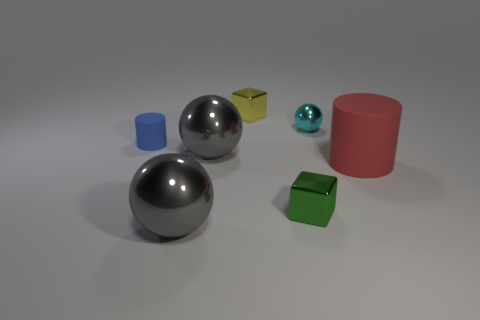How many red rubber things are behind the small blue cylinder?
Your response must be concise. 0. Does the tiny cube in front of the blue matte object have the same color as the big cylinder?
Your answer should be very brief. No. How many blue objects are either small rubber objects or big things?
Give a very brief answer. 1. There is a tiny cylinder that is left of the thing behind the small shiny sphere; what is its color?
Offer a very short reply. Blue. What is the color of the cylinder that is left of the cyan metal ball?
Give a very brief answer. Blue. Is the size of the cylinder that is left of the red cylinder the same as the small green thing?
Provide a succinct answer. Yes. Are there any purple objects of the same size as the yellow object?
Provide a succinct answer. No. Does the tiny block that is right of the yellow thing have the same color as the metal ball that is in front of the large red object?
Offer a very short reply. No. Are there any tiny things that have the same color as the big rubber object?
Offer a terse response. No. What number of other objects are there of the same shape as the tiny blue thing?
Give a very brief answer. 1. 